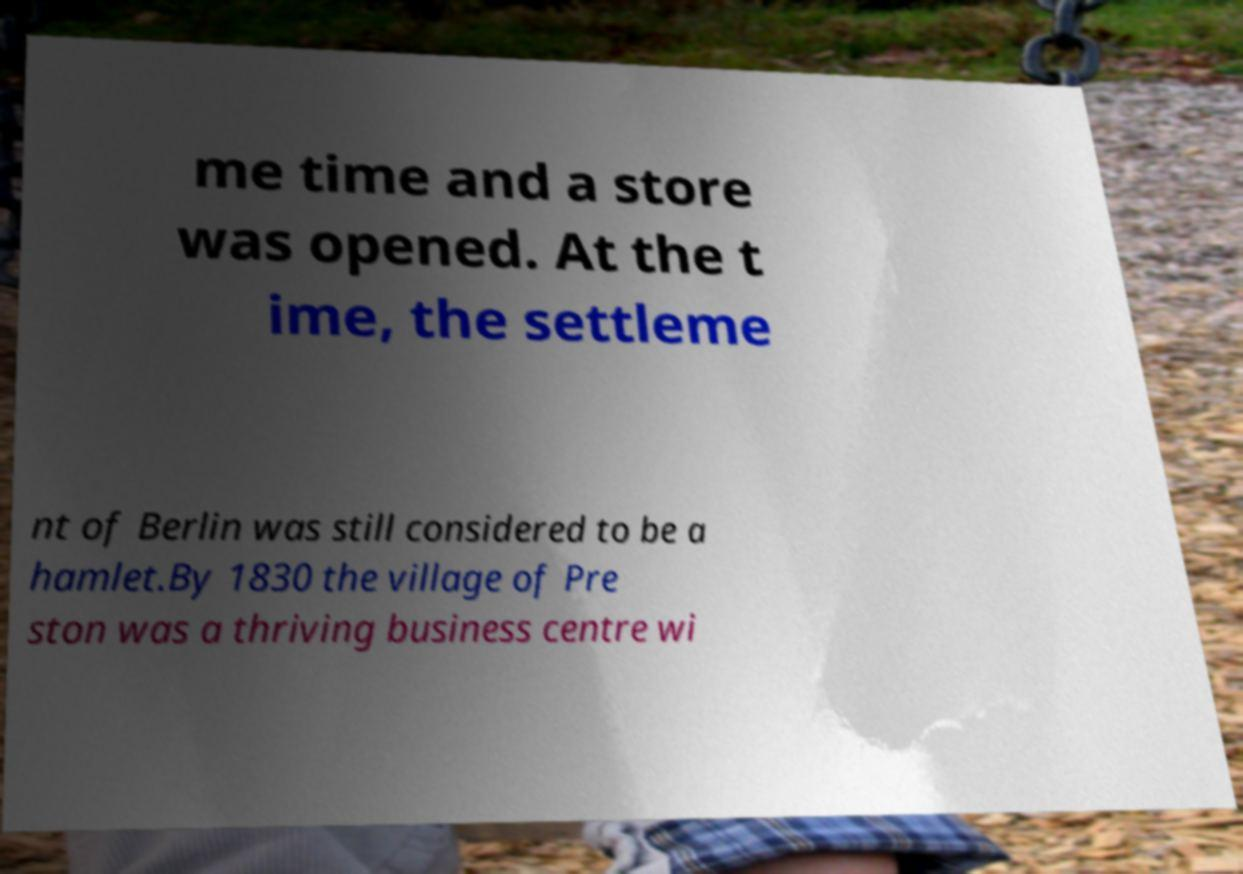There's text embedded in this image that I need extracted. Can you transcribe it verbatim? me time and a store was opened. At the t ime, the settleme nt of Berlin was still considered to be a hamlet.By 1830 the village of Pre ston was a thriving business centre wi 